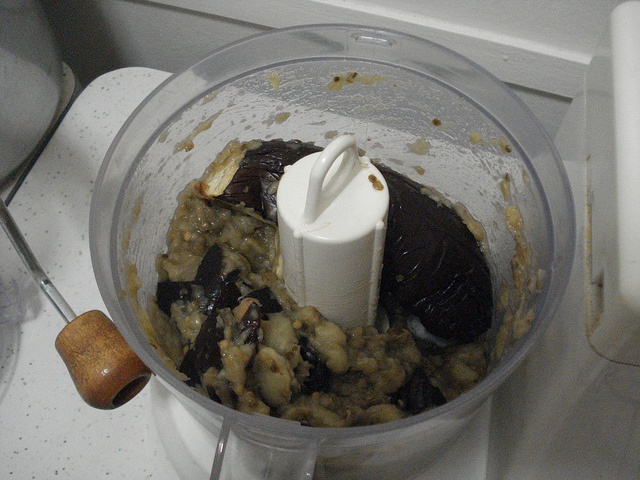Describe the objects in this image and their specific colors. I can see various objects in this image with different colors. 